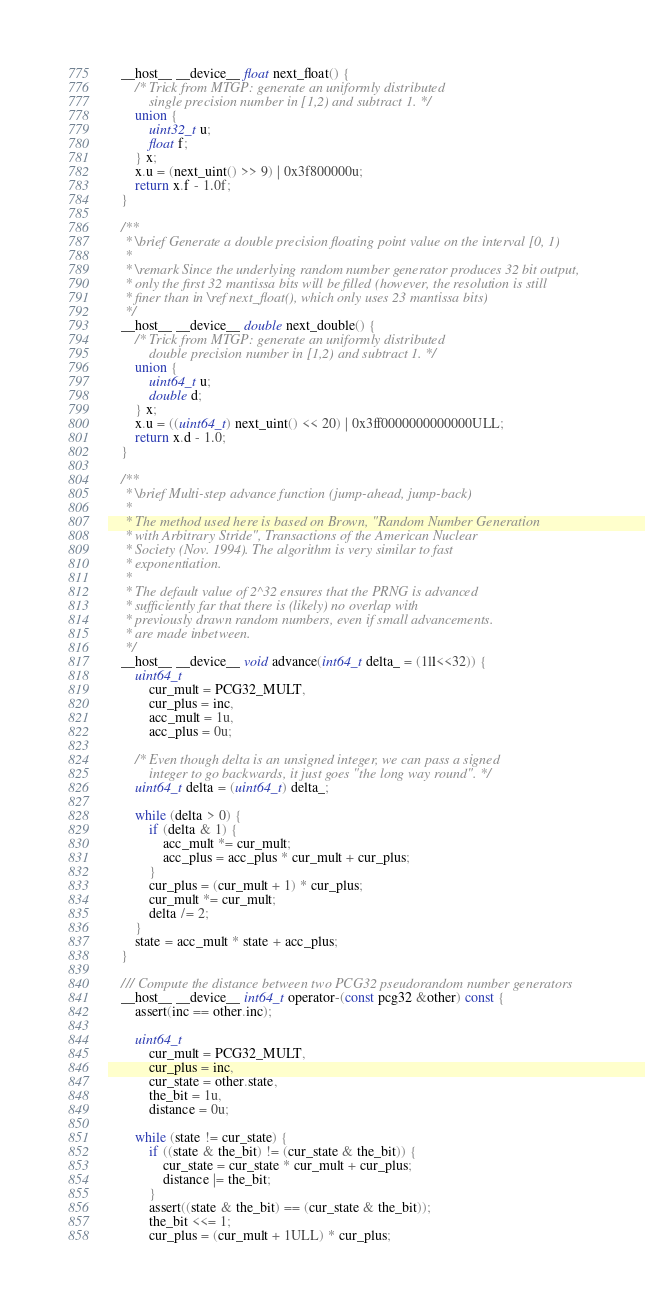Convert code to text. <code><loc_0><loc_0><loc_500><loc_500><_C_>	__host__ __device__ float next_float() {
		/* Trick from MTGP: generate an uniformly distributed
			single precision number in [1,2) and subtract 1. */
		union {
			uint32_t u;
			float f;
		} x;
		x.u = (next_uint() >> 9) | 0x3f800000u;
		return x.f - 1.0f;
	}

	/**
	 * \brief Generate a double precision floating point value on the interval [0, 1)
	 *
	 * \remark Since the underlying random number generator produces 32 bit output,
	 * only the first 32 mantissa bits will be filled (however, the resolution is still
	 * finer than in \ref next_float(), which only uses 23 mantissa bits)
	 */
	__host__ __device__ double next_double() {
		/* Trick from MTGP: generate an uniformly distributed
			double precision number in [1,2) and subtract 1. */
		union {
			uint64_t u;
			double d;
		} x;
		x.u = ((uint64_t) next_uint() << 20) | 0x3ff0000000000000ULL;
		return x.d - 1.0;
	}

	/**
	 * \brief Multi-step advance function (jump-ahead, jump-back)
	 *
	 * The method used here is based on Brown, "Random Number Generation
	 * with Arbitrary Stride", Transactions of the American Nuclear
	 * Society (Nov. 1994). The algorithm is very similar to fast
	 * exponentiation.
	 *
	 * The default value of 2^32 ensures that the PRNG is advanced
	 * sufficiently far that there is (likely) no overlap with
	 * previously drawn random numbers, even if small advancements.
	 * are made inbetween.
	 */
	__host__ __device__ void advance(int64_t delta_ = (1ll<<32)) {
		uint64_t
			cur_mult = PCG32_MULT,
			cur_plus = inc,
			acc_mult = 1u,
			acc_plus = 0u;

		/* Even though delta is an unsigned integer, we can pass a signed
			integer to go backwards, it just goes "the long way round". */
		uint64_t delta = (uint64_t) delta_;

		while (delta > 0) {
			if (delta & 1) {
				acc_mult *= cur_mult;
				acc_plus = acc_plus * cur_mult + cur_plus;
			}
			cur_plus = (cur_mult + 1) * cur_plus;
			cur_mult *= cur_mult;
			delta /= 2;
		}
		state = acc_mult * state + acc_plus;
	}

	/// Compute the distance between two PCG32 pseudorandom number generators
	__host__ __device__ int64_t operator-(const pcg32 &other) const {
		assert(inc == other.inc);

		uint64_t
			cur_mult = PCG32_MULT,
			cur_plus = inc,
			cur_state = other.state,
			the_bit = 1u,
			distance = 0u;

		while (state != cur_state) {
			if ((state & the_bit) != (cur_state & the_bit)) {
				cur_state = cur_state * cur_mult + cur_plus;
				distance |= the_bit;
			}
			assert((state & the_bit) == (cur_state & the_bit));
			the_bit <<= 1;
			cur_plus = (cur_mult + 1ULL) * cur_plus;</code> 